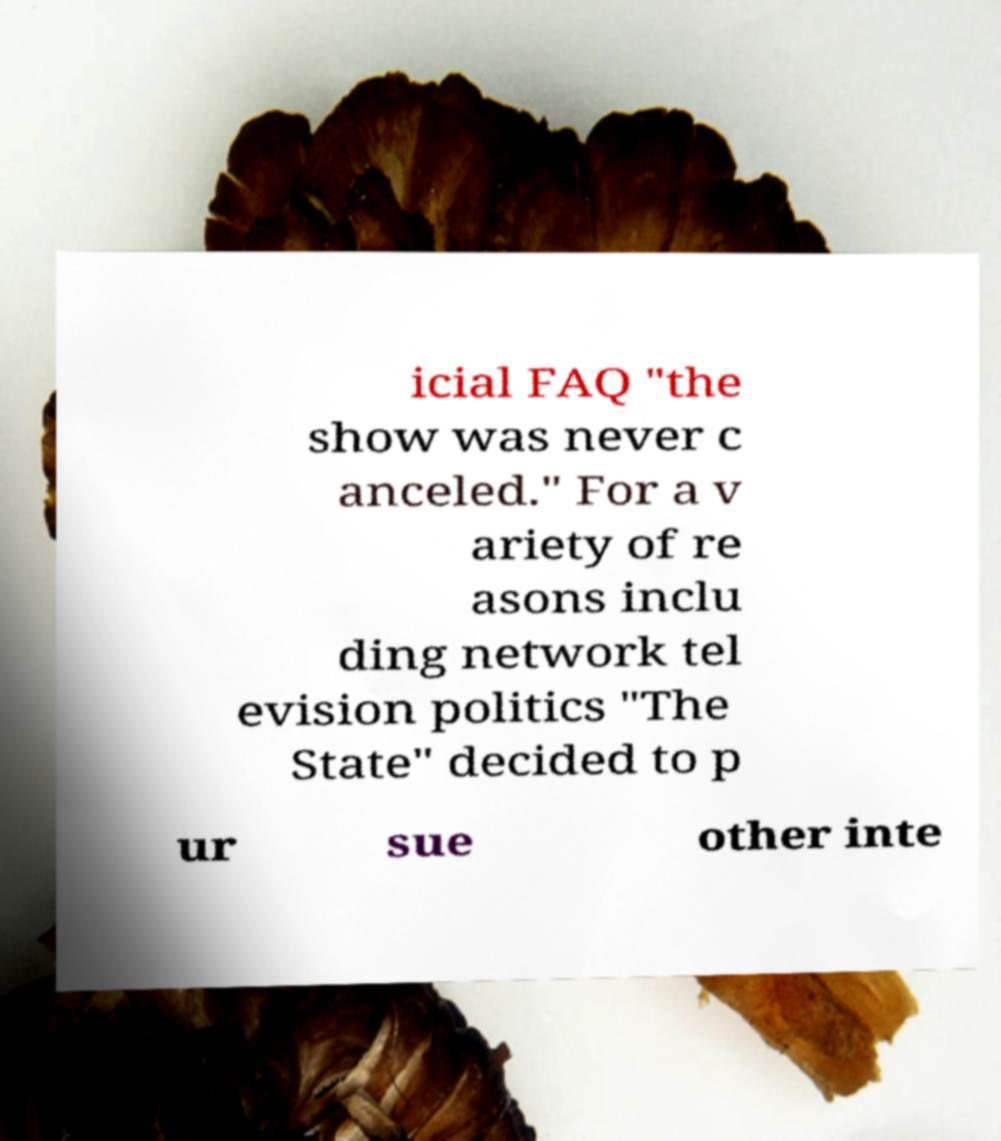For documentation purposes, I need the text within this image transcribed. Could you provide that? icial FAQ "the show was never c anceled." For a v ariety of re asons inclu ding network tel evision politics "The State" decided to p ur sue other inte 